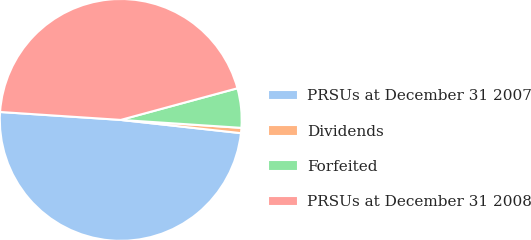Convert chart to OTSL. <chart><loc_0><loc_0><loc_500><loc_500><pie_chart><fcel>PRSUs at December 31 2007<fcel>Dividends<fcel>Forfeited<fcel>PRSUs at December 31 2008<nl><fcel>49.3%<fcel>0.7%<fcel>5.26%<fcel>44.74%<nl></chart> 